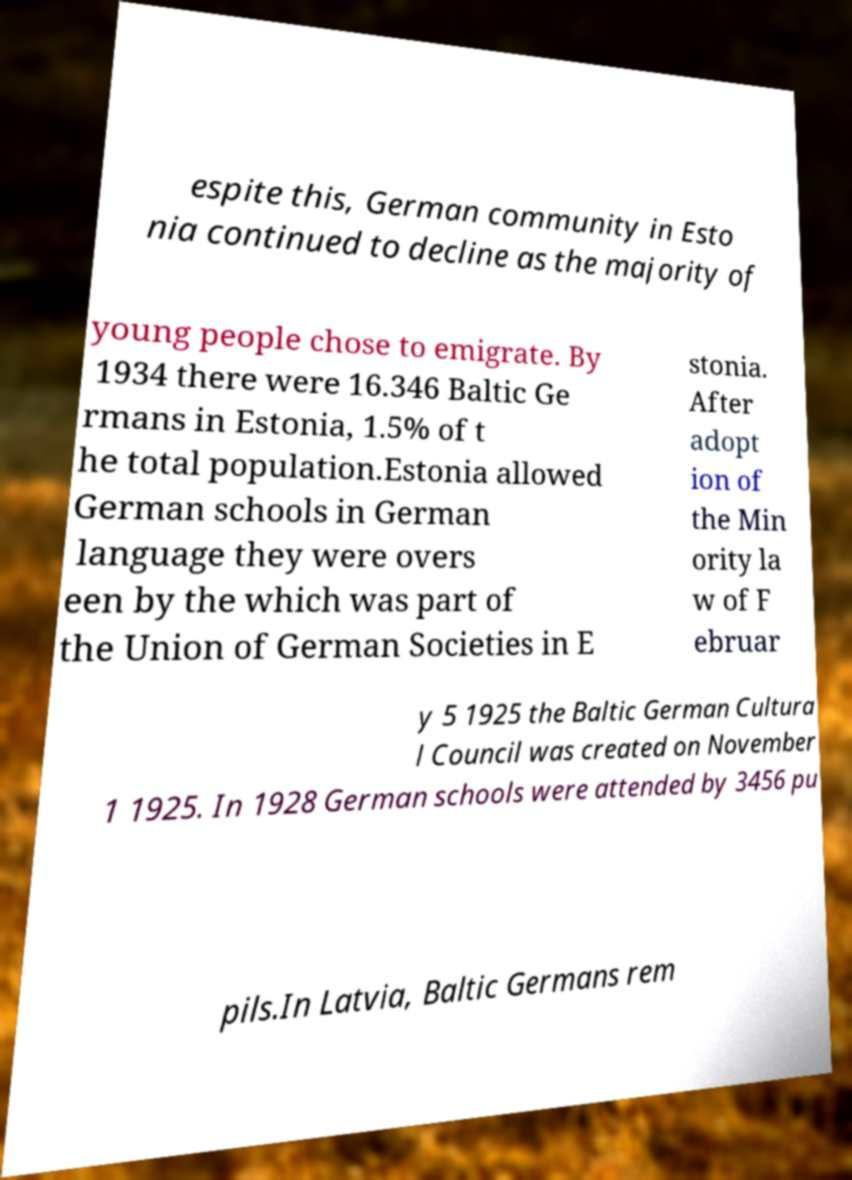Could you extract and type out the text from this image? espite this, German community in Esto nia continued to decline as the majority of young people chose to emigrate. By 1934 there were 16.346 Baltic Ge rmans in Estonia, 1.5% of t he total population.Estonia allowed German schools in German language they were overs een by the which was part of the Union of German Societies in E stonia. After adopt ion of the Min ority la w of F ebruar y 5 1925 the Baltic German Cultura l Council was created on November 1 1925. In 1928 German schools were attended by 3456 pu pils.In Latvia, Baltic Germans rem 